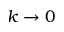Convert formula to latex. <formula><loc_0><loc_0><loc_500><loc_500>k \rightarrow 0</formula> 